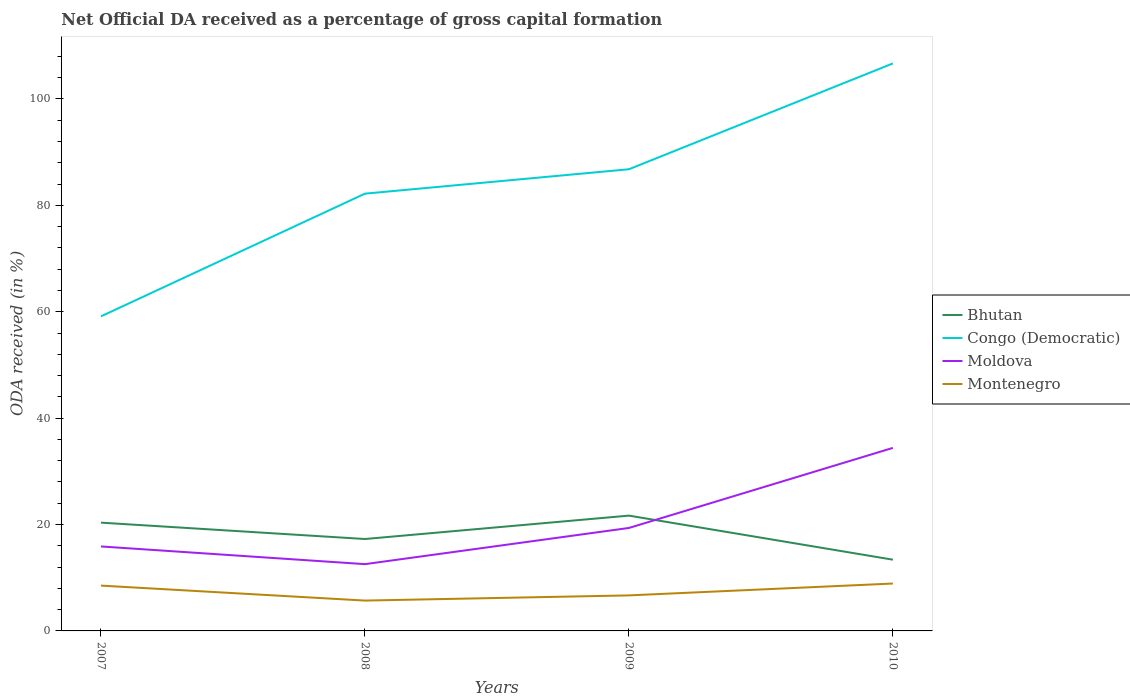Is the number of lines equal to the number of legend labels?
Give a very brief answer. Yes. Across all years, what is the maximum net ODA received in Bhutan?
Ensure brevity in your answer.  13.39. In which year was the net ODA received in Bhutan maximum?
Provide a succinct answer. 2010. What is the total net ODA received in Congo (Democratic) in the graph?
Provide a succinct answer. -27.65. What is the difference between the highest and the second highest net ODA received in Congo (Democratic)?
Your answer should be very brief. 47.54. Is the net ODA received in Congo (Democratic) strictly greater than the net ODA received in Montenegro over the years?
Give a very brief answer. No. How many lines are there?
Keep it short and to the point. 4. How many years are there in the graph?
Your answer should be compact. 4. What is the difference between two consecutive major ticks on the Y-axis?
Provide a short and direct response. 20. How are the legend labels stacked?
Provide a short and direct response. Vertical. What is the title of the graph?
Provide a succinct answer. Net Official DA received as a percentage of gross capital formation. Does "Latin America(developing only)" appear as one of the legend labels in the graph?
Provide a succinct answer. No. What is the label or title of the Y-axis?
Give a very brief answer. ODA received (in %). What is the ODA received (in %) of Bhutan in 2007?
Ensure brevity in your answer.  20.35. What is the ODA received (in %) of Congo (Democratic) in 2007?
Provide a succinct answer. 59.13. What is the ODA received (in %) of Moldova in 2007?
Your answer should be compact. 15.88. What is the ODA received (in %) of Montenegro in 2007?
Ensure brevity in your answer.  8.52. What is the ODA received (in %) of Bhutan in 2008?
Give a very brief answer. 17.28. What is the ODA received (in %) of Congo (Democratic) in 2008?
Offer a terse response. 82.2. What is the ODA received (in %) of Moldova in 2008?
Provide a short and direct response. 12.55. What is the ODA received (in %) of Montenegro in 2008?
Provide a short and direct response. 5.7. What is the ODA received (in %) of Bhutan in 2009?
Provide a succinct answer. 21.67. What is the ODA received (in %) of Congo (Democratic) in 2009?
Your answer should be compact. 86.78. What is the ODA received (in %) of Moldova in 2009?
Provide a short and direct response. 19.36. What is the ODA received (in %) of Montenegro in 2009?
Ensure brevity in your answer.  6.68. What is the ODA received (in %) of Bhutan in 2010?
Keep it short and to the point. 13.39. What is the ODA received (in %) in Congo (Democratic) in 2010?
Provide a succinct answer. 106.68. What is the ODA received (in %) of Moldova in 2010?
Make the answer very short. 34.41. What is the ODA received (in %) of Montenegro in 2010?
Your answer should be very brief. 8.91. Across all years, what is the maximum ODA received (in %) of Bhutan?
Your answer should be very brief. 21.67. Across all years, what is the maximum ODA received (in %) of Congo (Democratic)?
Your answer should be compact. 106.68. Across all years, what is the maximum ODA received (in %) in Moldova?
Your answer should be compact. 34.41. Across all years, what is the maximum ODA received (in %) of Montenegro?
Your answer should be compact. 8.91. Across all years, what is the minimum ODA received (in %) in Bhutan?
Provide a succinct answer. 13.39. Across all years, what is the minimum ODA received (in %) of Congo (Democratic)?
Offer a terse response. 59.13. Across all years, what is the minimum ODA received (in %) in Moldova?
Ensure brevity in your answer.  12.55. Across all years, what is the minimum ODA received (in %) in Montenegro?
Your answer should be very brief. 5.7. What is the total ODA received (in %) of Bhutan in the graph?
Offer a terse response. 72.7. What is the total ODA received (in %) in Congo (Democratic) in the graph?
Provide a short and direct response. 334.79. What is the total ODA received (in %) of Moldova in the graph?
Give a very brief answer. 82.19. What is the total ODA received (in %) in Montenegro in the graph?
Your answer should be very brief. 29.81. What is the difference between the ODA received (in %) of Bhutan in 2007 and that in 2008?
Provide a succinct answer. 3.08. What is the difference between the ODA received (in %) in Congo (Democratic) in 2007 and that in 2008?
Offer a terse response. -23.07. What is the difference between the ODA received (in %) in Moldova in 2007 and that in 2008?
Your answer should be compact. 3.32. What is the difference between the ODA received (in %) in Montenegro in 2007 and that in 2008?
Provide a short and direct response. 2.81. What is the difference between the ODA received (in %) of Bhutan in 2007 and that in 2009?
Make the answer very short. -1.32. What is the difference between the ODA received (in %) in Congo (Democratic) in 2007 and that in 2009?
Keep it short and to the point. -27.65. What is the difference between the ODA received (in %) in Moldova in 2007 and that in 2009?
Make the answer very short. -3.48. What is the difference between the ODA received (in %) of Montenegro in 2007 and that in 2009?
Your response must be concise. 1.84. What is the difference between the ODA received (in %) in Bhutan in 2007 and that in 2010?
Ensure brevity in your answer.  6.96. What is the difference between the ODA received (in %) of Congo (Democratic) in 2007 and that in 2010?
Your answer should be very brief. -47.54. What is the difference between the ODA received (in %) of Moldova in 2007 and that in 2010?
Your response must be concise. -18.53. What is the difference between the ODA received (in %) of Montenegro in 2007 and that in 2010?
Provide a short and direct response. -0.39. What is the difference between the ODA received (in %) of Bhutan in 2008 and that in 2009?
Offer a very short reply. -4.4. What is the difference between the ODA received (in %) of Congo (Democratic) in 2008 and that in 2009?
Make the answer very short. -4.59. What is the difference between the ODA received (in %) in Moldova in 2008 and that in 2009?
Give a very brief answer. -6.8. What is the difference between the ODA received (in %) of Montenegro in 2008 and that in 2009?
Offer a very short reply. -0.98. What is the difference between the ODA received (in %) of Bhutan in 2008 and that in 2010?
Offer a terse response. 3.89. What is the difference between the ODA received (in %) of Congo (Democratic) in 2008 and that in 2010?
Keep it short and to the point. -24.48. What is the difference between the ODA received (in %) in Moldova in 2008 and that in 2010?
Provide a short and direct response. -21.85. What is the difference between the ODA received (in %) in Montenegro in 2008 and that in 2010?
Keep it short and to the point. -3.2. What is the difference between the ODA received (in %) in Bhutan in 2009 and that in 2010?
Provide a short and direct response. 8.28. What is the difference between the ODA received (in %) in Congo (Democratic) in 2009 and that in 2010?
Your answer should be very brief. -19.89. What is the difference between the ODA received (in %) of Moldova in 2009 and that in 2010?
Your answer should be very brief. -15.05. What is the difference between the ODA received (in %) of Montenegro in 2009 and that in 2010?
Give a very brief answer. -2.23. What is the difference between the ODA received (in %) in Bhutan in 2007 and the ODA received (in %) in Congo (Democratic) in 2008?
Ensure brevity in your answer.  -61.84. What is the difference between the ODA received (in %) in Bhutan in 2007 and the ODA received (in %) in Moldova in 2008?
Your answer should be very brief. 7.8. What is the difference between the ODA received (in %) of Bhutan in 2007 and the ODA received (in %) of Montenegro in 2008?
Offer a very short reply. 14.65. What is the difference between the ODA received (in %) in Congo (Democratic) in 2007 and the ODA received (in %) in Moldova in 2008?
Your response must be concise. 46.58. What is the difference between the ODA received (in %) of Congo (Democratic) in 2007 and the ODA received (in %) of Montenegro in 2008?
Offer a terse response. 53.43. What is the difference between the ODA received (in %) in Moldova in 2007 and the ODA received (in %) in Montenegro in 2008?
Offer a terse response. 10.17. What is the difference between the ODA received (in %) of Bhutan in 2007 and the ODA received (in %) of Congo (Democratic) in 2009?
Your response must be concise. -66.43. What is the difference between the ODA received (in %) of Bhutan in 2007 and the ODA received (in %) of Montenegro in 2009?
Keep it short and to the point. 13.67. What is the difference between the ODA received (in %) in Congo (Democratic) in 2007 and the ODA received (in %) in Moldova in 2009?
Provide a short and direct response. 39.78. What is the difference between the ODA received (in %) in Congo (Democratic) in 2007 and the ODA received (in %) in Montenegro in 2009?
Keep it short and to the point. 52.45. What is the difference between the ODA received (in %) in Moldova in 2007 and the ODA received (in %) in Montenegro in 2009?
Your response must be concise. 9.2. What is the difference between the ODA received (in %) in Bhutan in 2007 and the ODA received (in %) in Congo (Democratic) in 2010?
Keep it short and to the point. -86.32. What is the difference between the ODA received (in %) in Bhutan in 2007 and the ODA received (in %) in Moldova in 2010?
Ensure brevity in your answer.  -14.05. What is the difference between the ODA received (in %) of Bhutan in 2007 and the ODA received (in %) of Montenegro in 2010?
Your answer should be compact. 11.44. What is the difference between the ODA received (in %) in Congo (Democratic) in 2007 and the ODA received (in %) in Moldova in 2010?
Your response must be concise. 24.73. What is the difference between the ODA received (in %) in Congo (Democratic) in 2007 and the ODA received (in %) in Montenegro in 2010?
Offer a terse response. 50.22. What is the difference between the ODA received (in %) in Moldova in 2007 and the ODA received (in %) in Montenegro in 2010?
Ensure brevity in your answer.  6.97. What is the difference between the ODA received (in %) of Bhutan in 2008 and the ODA received (in %) of Congo (Democratic) in 2009?
Offer a terse response. -69.51. What is the difference between the ODA received (in %) of Bhutan in 2008 and the ODA received (in %) of Moldova in 2009?
Offer a terse response. -2.08. What is the difference between the ODA received (in %) of Bhutan in 2008 and the ODA received (in %) of Montenegro in 2009?
Give a very brief answer. 10.6. What is the difference between the ODA received (in %) of Congo (Democratic) in 2008 and the ODA received (in %) of Moldova in 2009?
Your answer should be very brief. 62.84. What is the difference between the ODA received (in %) of Congo (Democratic) in 2008 and the ODA received (in %) of Montenegro in 2009?
Provide a short and direct response. 75.52. What is the difference between the ODA received (in %) in Moldova in 2008 and the ODA received (in %) in Montenegro in 2009?
Give a very brief answer. 5.87. What is the difference between the ODA received (in %) of Bhutan in 2008 and the ODA received (in %) of Congo (Democratic) in 2010?
Your answer should be very brief. -89.4. What is the difference between the ODA received (in %) of Bhutan in 2008 and the ODA received (in %) of Moldova in 2010?
Offer a terse response. -17.13. What is the difference between the ODA received (in %) in Bhutan in 2008 and the ODA received (in %) in Montenegro in 2010?
Make the answer very short. 8.37. What is the difference between the ODA received (in %) in Congo (Democratic) in 2008 and the ODA received (in %) in Moldova in 2010?
Your response must be concise. 47.79. What is the difference between the ODA received (in %) in Congo (Democratic) in 2008 and the ODA received (in %) in Montenegro in 2010?
Provide a succinct answer. 73.29. What is the difference between the ODA received (in %) of Moldova in 2008 and the ODA received (in %) of Montenegro in 2010?
Offer a very short reply. 3.64. What is the difference between the ODA received (in %) in Bhutan in 2009 and the ODA received (in %) in Congo (Democratic) in 2010?
Provide a short and direct response. -85. What is the difference between the ODA received (in %) of Bhutan in 2009 and the ODA received (in %) of Moldova in 2010?
Ensure brevity in your answer.  -12.73. What is the difference between the ODA received (in %) of Bhutan in 2009 and the ODA received (in %) of Montenegro in 2010?
Ensure brevity in your answer.  12.77. What is the difference between the ODA received (in %) of Congo (Democratic) in 2009 and the ODA received (in %) of Moldova in 2010?
Ensure brevity in your answer.  52.38. What is the difference between the ODA received (in %) of Congo (Democratic) in 2009 and the ODA received (in %) of Montenegro in 2010?
Make the answer very short. 77.87. What is the difference between the ODA received (in %) in Moldova in 2009 and the ODA received (in %) in Montenegro in 2010?
Give a very brief answer. 10.45. What is the average ODA received (in %) in Bhutan per year?
Provide a short and direct response. 18.17. What is the average ODA received (in %) in Congo (Democratic) per year?
Keep it short and to the point. 83.7. What is the average ODA received (in %) of Moldova per year?
Provide a succinct answer. 20.55. What is the average ODA received (in %) of Montenegro per year?
Ensure brevity in your answer.  7.45. In the year 2007, what is the difference between the ODA received (in %) of Bhutan and ODA received (in %) of Congo (Democratic)?
Provide a short and direct response. -38.78. In the year 2007, what is the difference between the ODA received (in %) in Bhutan and ODA received (in %) in Moldova?
Offer a terse response. 4.48. In the year 2007, what is the difference between the ODA received (in %) of Bhutan and ODA received (in %) of Montenegro?
Your answer should be compact. 11.84. In the year 2007, what is the difference between the ODA received (in %) of Congo (Democratic) and ODA received (in %) of Moldova?
Offer a terse response. 43.25. In the year 2007, what is the difference between the ODA received (in %) of Congo (Democratic) and ODA received (in %) of Montenegro?
Ensure brevity in your answer.  50.61. In the year 2007, what is the difference between the ODA received (in %) of Moldova and ODA received (in %) of Montenegro?
Make the answer very short. 7.36. In the year 2008, what is the difference between the ODA received (in %) in Bhutan and ODA received (in %) in Congo (Democratic)?
Offer a terse response. -64.92. In the year 2008, what is the difference between the ODA received (in %) of Bhutan and ODA received (in %) of Moldova?
Ensure brevity in your answer.  4.72. In the year 2008, what is the difference between the ODA received (in %) in Bhutan and ODA received (in %) in Montenegro?
Your response must be concise. 11.57. In the year 2008, what is the difference between the ODA received (in %) of Congo (Democratic) and ODA received (in %) of Moldova?
Your answer should be very brief. 69.64. In the year 2008, what is the difference between the ODA received (in %) of Congo (Democratic) and ODA received (in %) of Montenegro?
Provide a succinct answer. 76.49. In the year 2008, what is the difference between the ODA received (in %) in Moldova and ODA received (in %) in Montenegro?
Offer a terse response. 6.85. In the year 2009, what is the difference between the ODA received (in %) of Bhutan and ODA received (in %) of Congo (Democratic)?
Offer a terse response. -65.11. In the year 2009, what is the difference between the ODA received (in %) in Bhutan and ODA received (in %) in Moldova?
Your answer should be compact. 2.32. In the year 2009, what is the difference between the ODA received (in %) in Bhutan and ODA received (in %) in Montenegro?
Your answer should be compact. 14.99. In the year 2009, what is the difference between the ODA received (in %) in Congo (Democratic) and ODA received (in %) in Moldova?
Your answer should be very brief. 67.43. In the year 2009, what is the difference between the ODA received (in %) of Congo (Democratic) and ODA received (in %) of Montenegro?
Offer a very short reply. 80.1. In the year 2009, what is the difference between the ODA received (in %) in Moldova and ODA received (in %) in Montenegro?
Offer a terse response. 12.68. In the year 2010, what is the difference between the ODA received (in %) in Bhutan and ODA received (in %) in Congo (Democratic)?
Your answer should be very brief. -93.29. In the year 2010, what is the difference between the ODA received (in %) of Bhutan and ODA received (in %) of Moldova?
Your answer should be very brief. -21.02. In the year 2010, what is the difference between the ODA received (in %) in Bhutan and ODA received (in %) in Montenegro?
Give a very brief answer. 4.48. In the year 2010, what is the difference between the ODA received (in %) in Congo (Democratic) and ODA received (in %) in Moldova?
Your response must be concise. 72.27. In the year 2010, what is the difference between the ODA received (in %) of Congo (Democratic) and ODA received (in %) of Montenegro?
Make the answer very short. 97.77. In the year 2010, what is the difference between the ODA received (in %) in Moldova and ODA received (in %) in Montenegro?
Your answer should be very brief. 25.5. What is the ratio of the ODA received (in %) in Bhutan in 2007 to that in 2008?
Your response must be concise. 1.18. What is the ratio of the ODA received (in %) in Congo (Democratic) in 2007 to that in 2008?
Your answer should be very brief. 0.72. What is the ratio of the ODA received (in %) of Moldova in 2007 to that in 2008?
Ensure brevity in your answer.  1.26. What is the ratio of the ODA received (in %) in Montenegro in 2007 to that in 2008?
Your answer should be very brief. 1.49. What is the ratio of the ODA received (in %) of Bhutan in 2007 to that in 2009?
Offer a terse response. 0.94. What is the ratio of the ODA received (in %) in Congo (Democratic) in 2007 to that in 2009?
Keep it short and to the point. 0.68. What is the ratio of the ODA received (in %) in Moldova in 2007 to that in 2009?
Keep it short and to the point. 0.82. What is the ratio of the ODA received (in %) in Montenegro in 2007 to that in 2009?
Keep it short and to the point. 1.28. What is the ratio of the ODA received (in %) of Bhutan in 2007 to that in 2010?
Provide a short and direct response. 1.52. What is the ratio of the ODA received (in %) in Congo (Democratic) in 2007 to that in 2010?
Make the answer very short. 0.55. What is the ratio of the ODA received (in %) in Moldova in 2007 to that in 2010?
Your response must be concise. 0.46. What is the ratio of the ODA received (in %) of Montenegro in 2007 to that in 2010?
Ensure brevity in your answer.  0.96. What is the ratio of the ODA received (in %) in Bhutan in 2008 to that in 2009?
Give a very brief answer. 0.8. What is the ratio of the ODA received (in %) of Congo (Democratic) in 2008 to that in 2009?
Ensure brevity in your answer.  0.95. What is the ratio of the ODA received (in %) of Moldova in 2008 to that in 2009?
Make the answer very short. 0.65. What is the ratio of the ODA received (in %) of Montenegro in 2008 to that in 2009?
Offer a very short reply. 0.85. What is the ratio of the ODA received (in %) of Bhutan in 2008 to that in 2010?
Offer a terse response. 1.29. What is the ratio of the ODA received (in %) of Congo (Democratic) in 2008 to that in 2010?
Offer a very short reply. 0.77. What is the ratio of the ODA received (in %) of Moldova in 2008 to that in 2010?
Keep it short and to the point. 0.36. What is the ratio of the ODA received (in %) in Montenegro in 2008 to that in 2010?
Offer a very short reply. 0.64. What is the ratio of the ODA received (in %) in Bhutan in 2009 to that in 2010?
Offer a very short reply. 1.62. What is the ratio of the ODA received (in %) in Congo (Democratic) in 2009 to that in 2010?
Keep it short and to the point. 0.81. What is the ratio of the ODA received (in %) of Moldova in 2009 to that in 2010?
Keep it short and to the point. 0.56. What is the ratio of the ODA received (in %) of Montenegro in 2009 to that in 2010?
Ensure brevity in your answer.  0.75. What is the difference between the highest and the second highest ODA received (in %) of Bhutan?
Offer a terse response. 1.32. What is the difference between the highest and the second highest ODA received (in %) in Congo (Democratic)?
Give a very brief answer. 19.89. What is the difference between the highest and the second highest ODA received (in %) in Moldova?
Offer a very short reply. 15.05. What is the difference between the highest and the second highest ODA received (in %) in Montenegro?
Ensure brevity in your answer.  0.39. What is the difference between the highest and the lowest ODA received (in %) of Bhutan?
Make the answer very short. 8.28. What is the difference between the highest and the lowest ODA received (in %) in Congo (Democratic)?
Your answer should be very brief. 47.54. What is the difference between the highest and the lowest ODA received (in %) in Moldova?
Ensure brevity in your answer.  21.85. What is the difference between the highest and the lowest ODA received (in %) of Montenegro?
Provide a succinct answer. 3.2. 